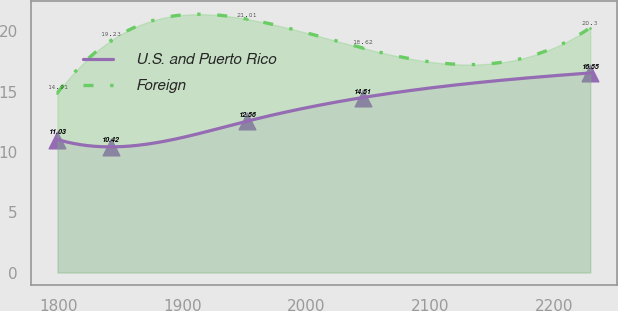Convert chart. <chart><loc_0><loc_0><loc_500><loc_500><line_chart><ecel><fcel>U.S. and Puerto Rico<fcel>Foreign<nl><fcel>1799.05<fcel>11.03<fcel>14.91<nl><fcel>1842.03<fcel>10.42<fcel>19.23<nl><fcel>1952.32<fcel>12.56<fcel>21.01<nl><fcel>2045.22<fcel>14.51<fcel>18.62<nl><fcel>2228.85<fcel>16.55<fcel>20.3<nl></chart> 